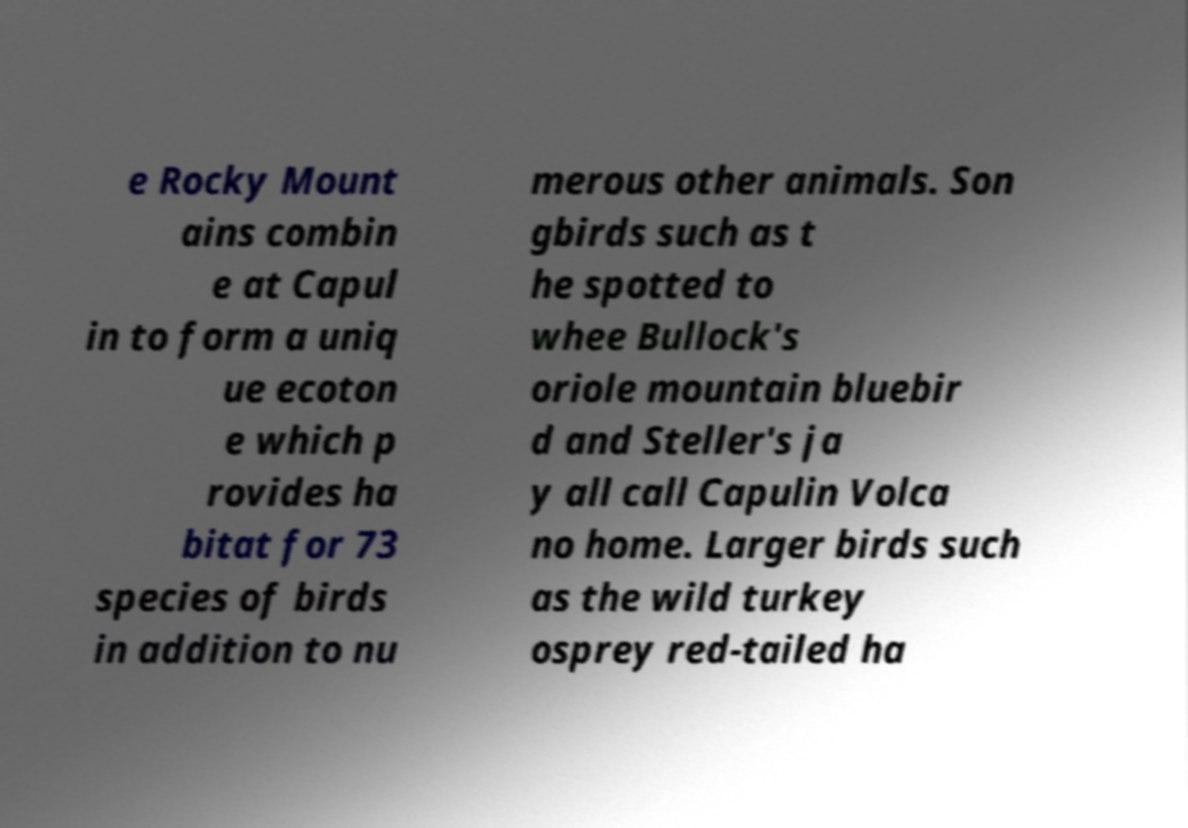For documentation purposes, I need the text within this image transcribed. Could you provide that? e Rocky Mount ains combin e at Capul in to form a uniq ue ecoton e which p rovides ha bitat for 73 species of birds in addition to nu merous other animals. Son gbirds such as t he spotted to whee Bullock's oriole mountain bluebir d and Steller's ja y all call Capulin Volca no home. Larger birds such as the wild turkey osprey red-tailed ha 